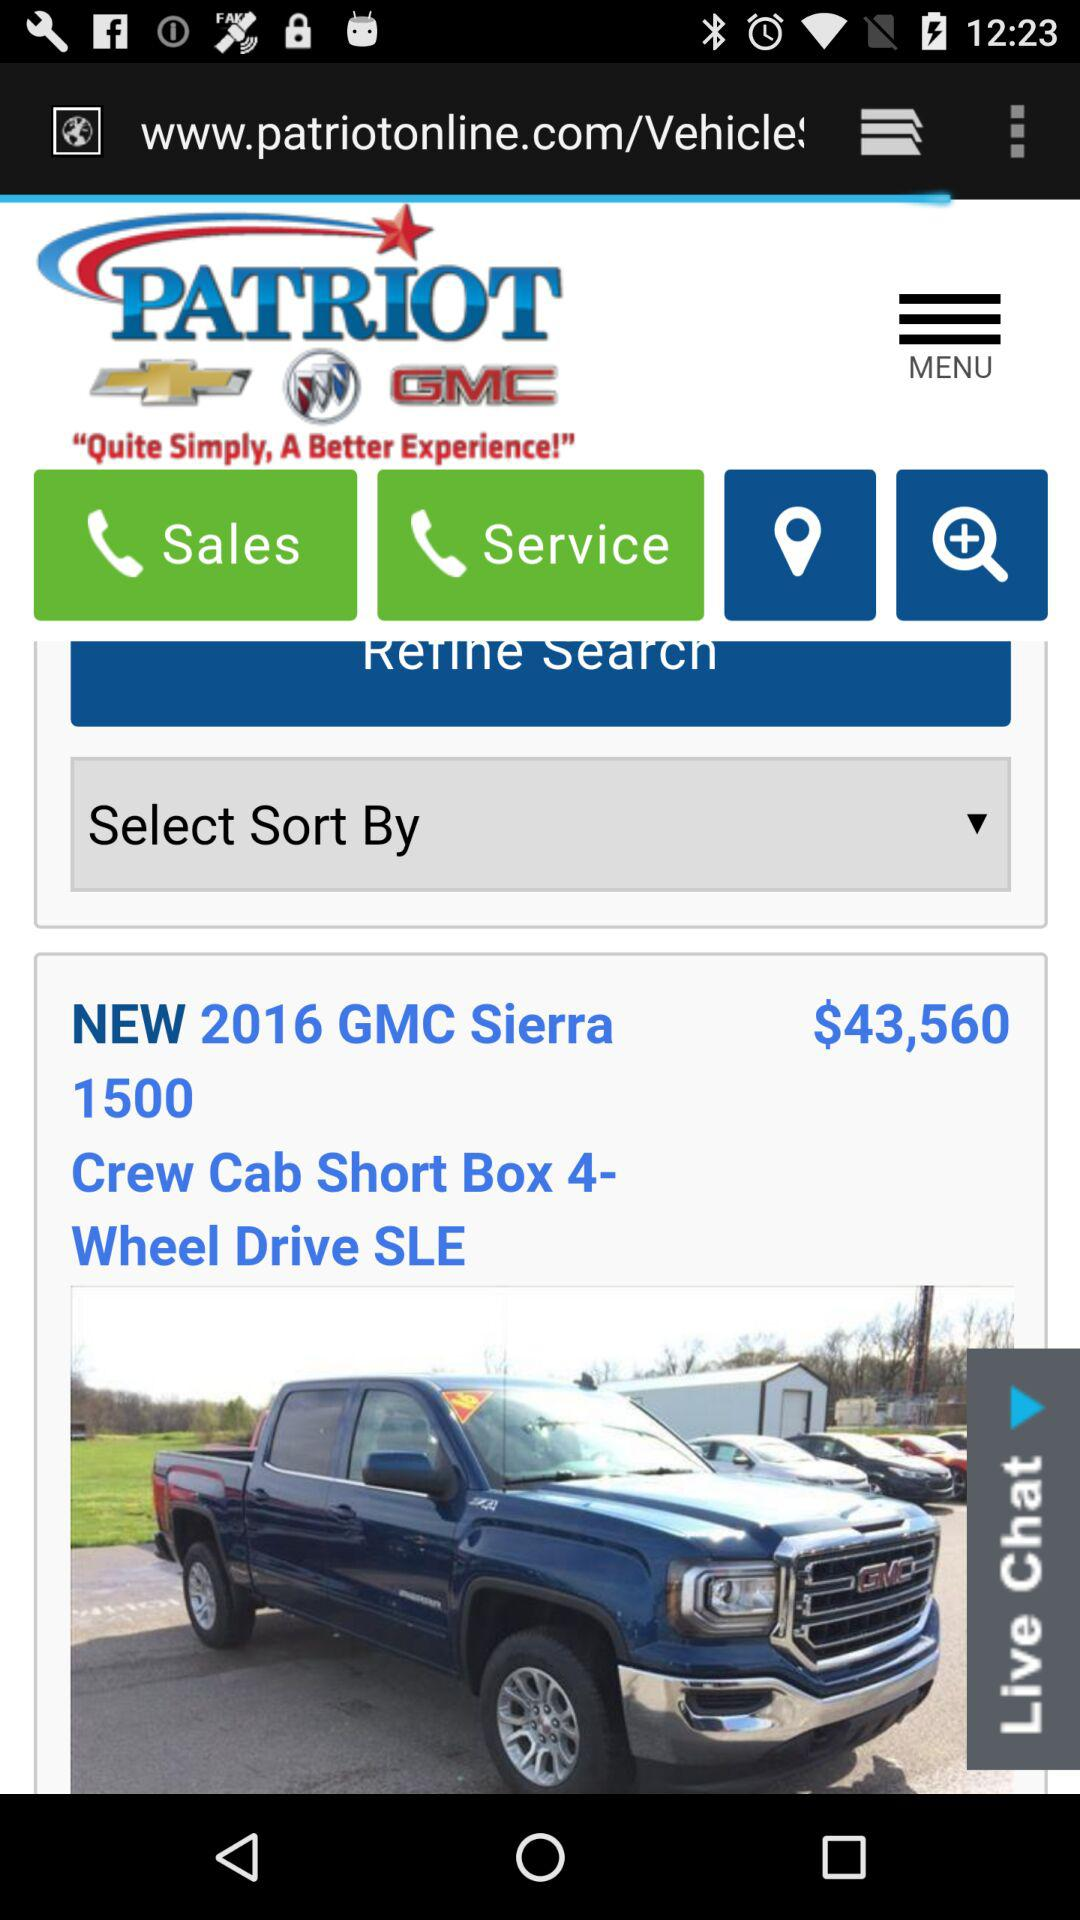What is the price of "New 2016 GMC Sierra 1500"? The price is $43,560. 